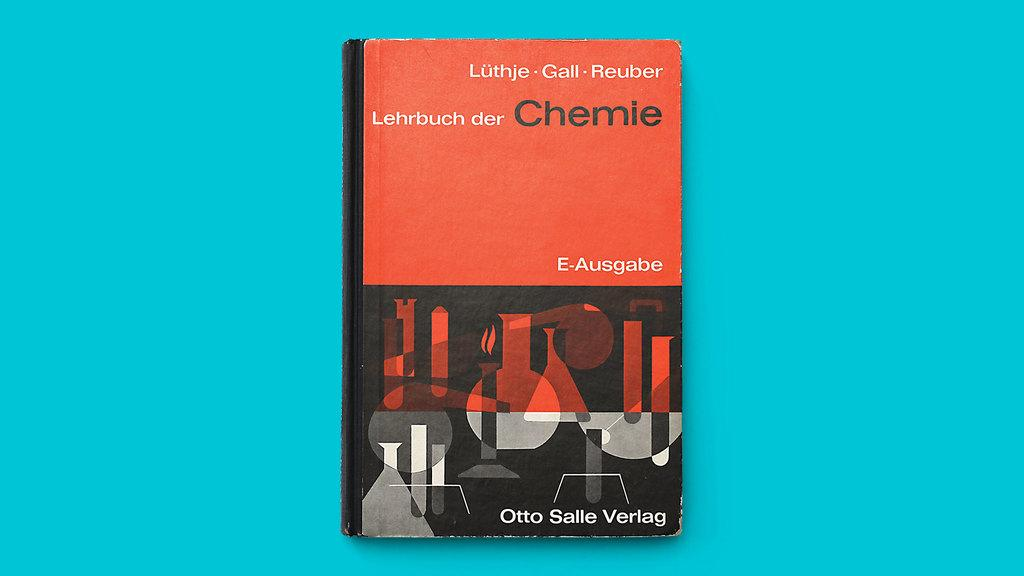Provide a one-sentence caption for the provided image. A business card for a man named Otto Salle Verlag. 